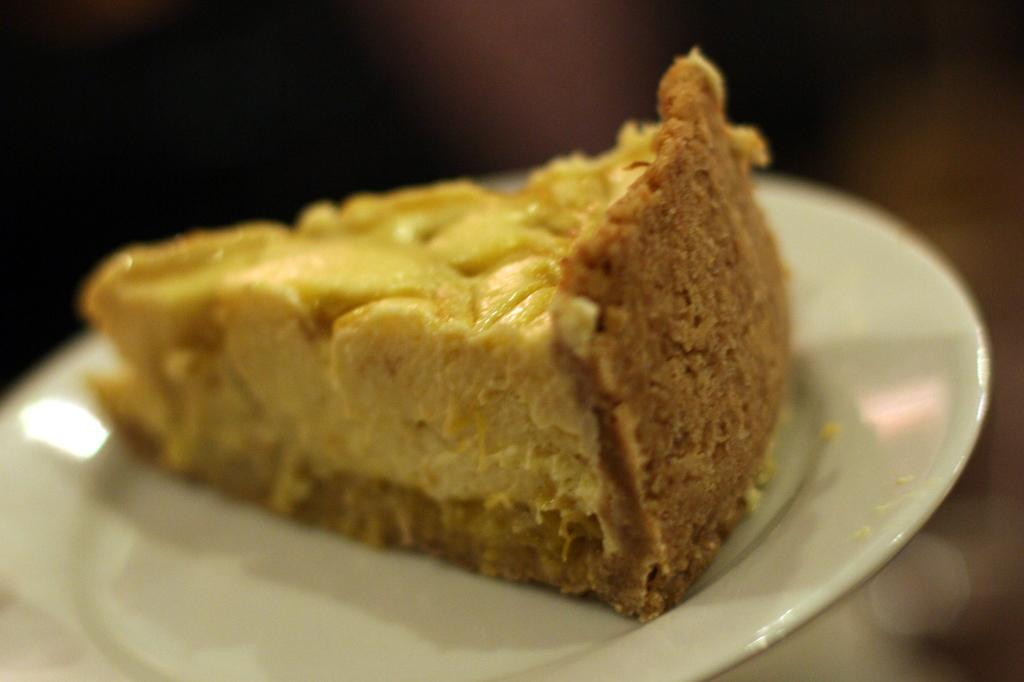What object is present on the plate in the image? There is a piece of food on the plate in the image. What color is the plate in the image? The plate in the image is white. Can you describe the background of the image? The background of the image is blurred. What organization is responsible for the degree of the person in the image? There is no person or degree present in the image, so it is not possible to determine which organization might be responsible. 